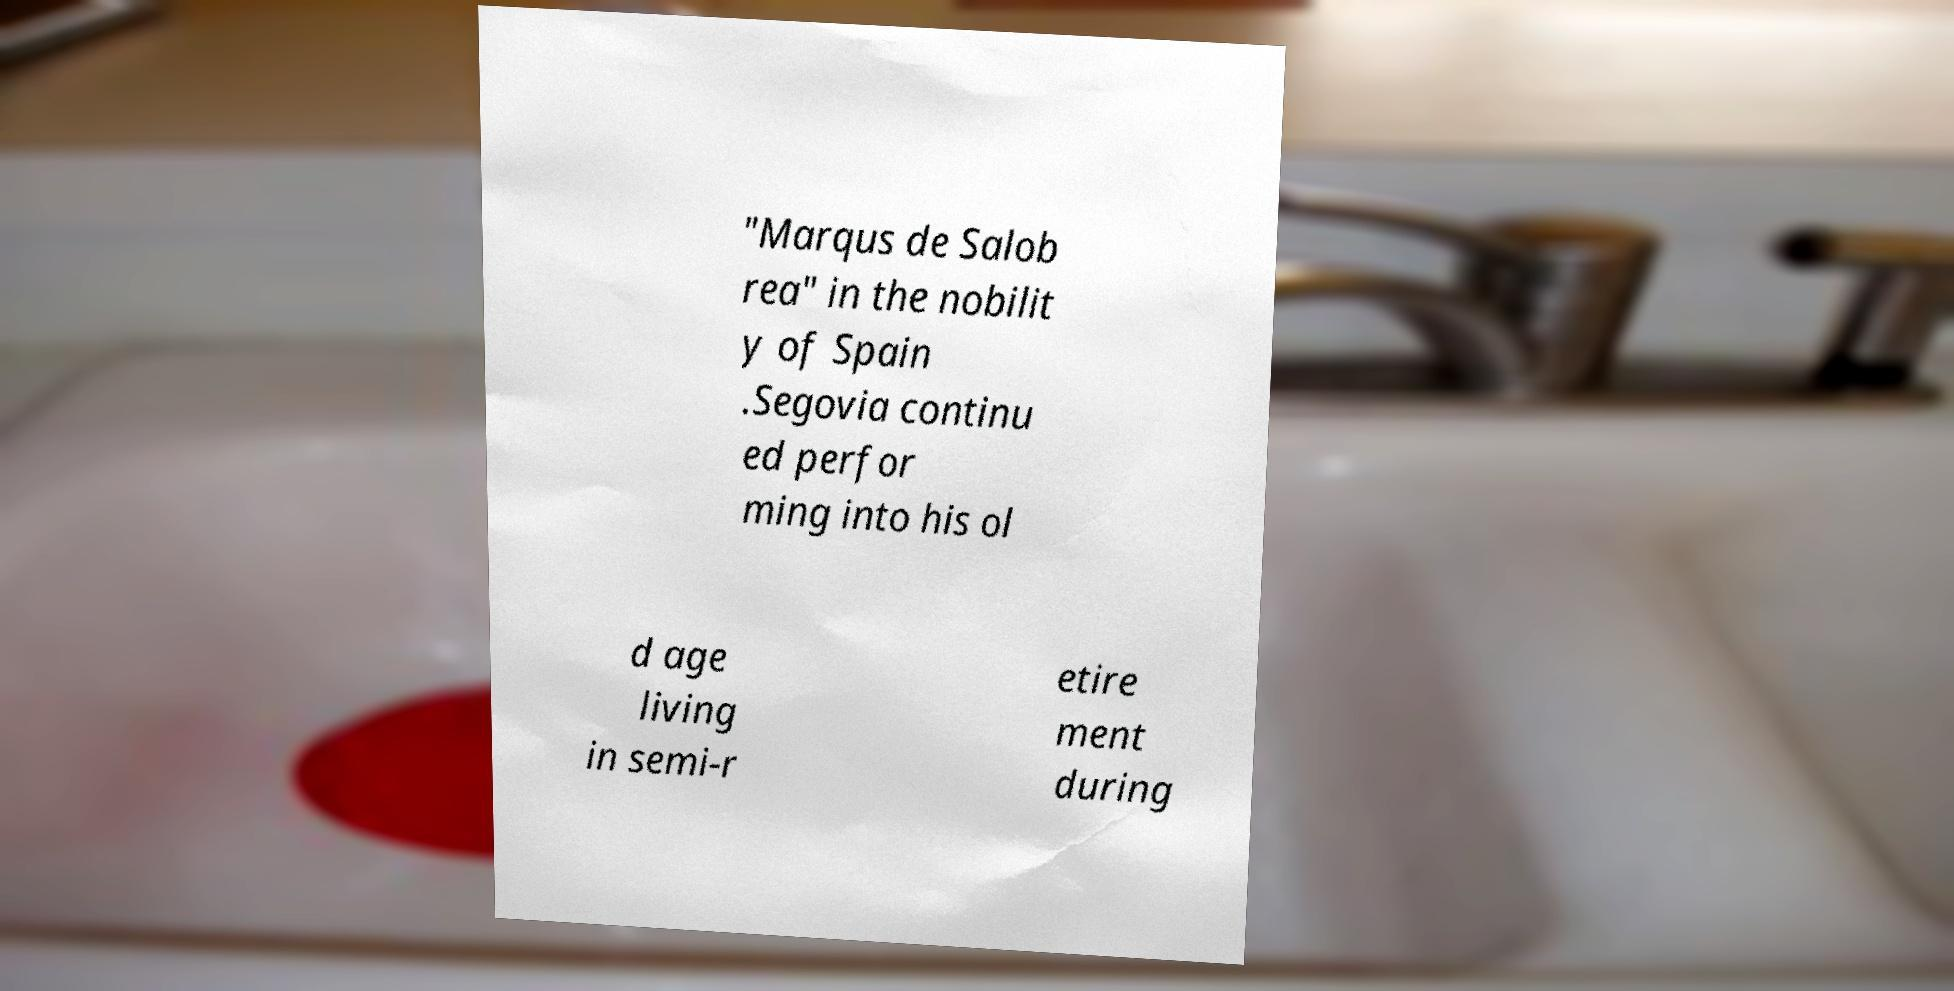There's text embedded in this image that I need extracted. Can you transcribe it verbatim? "Marqus de Salob rea" in the nobilit y of Spain .Segovia continu ed perfor ming into his ol d age living in semi-r etire ment during 